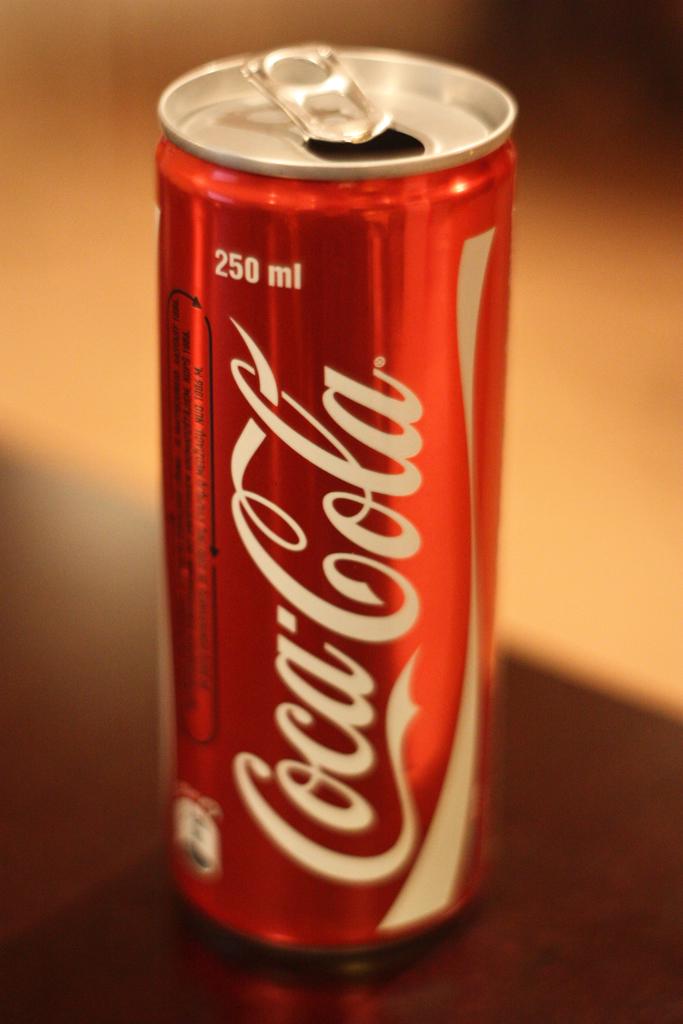What company makes this drink?
Provide a succinct answer. Coca-cola. How many milliliters does this can hold?
Keep it short and to the point. 250. 